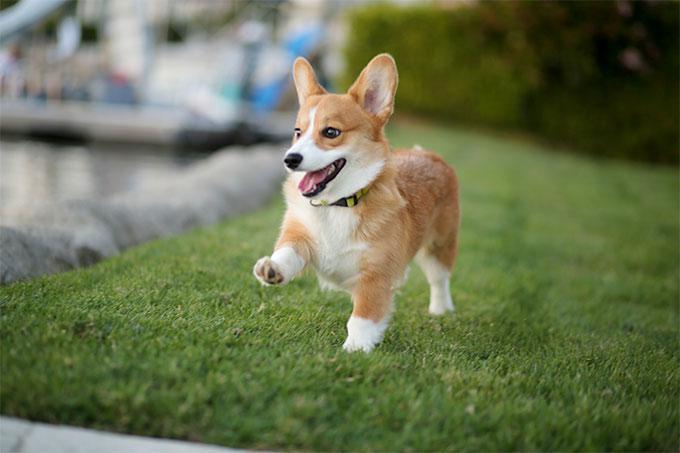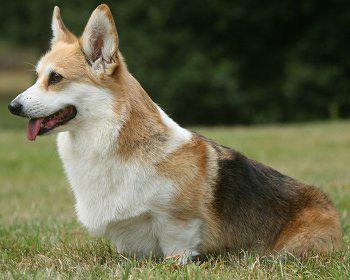The first image is the image on the left, the second image is the image on the right. Considering the images on both sides, is "An image includes an orange-and-white dog walking toward the camera on grass." valid? Answer yes or no. Yes. The first image is the image on the left, the second image is the image on the right. Considering the images on both sides, is "The dog in the left image is brown/red and white; there is no black in the fur." valid? Answer yes or no. Yes. 